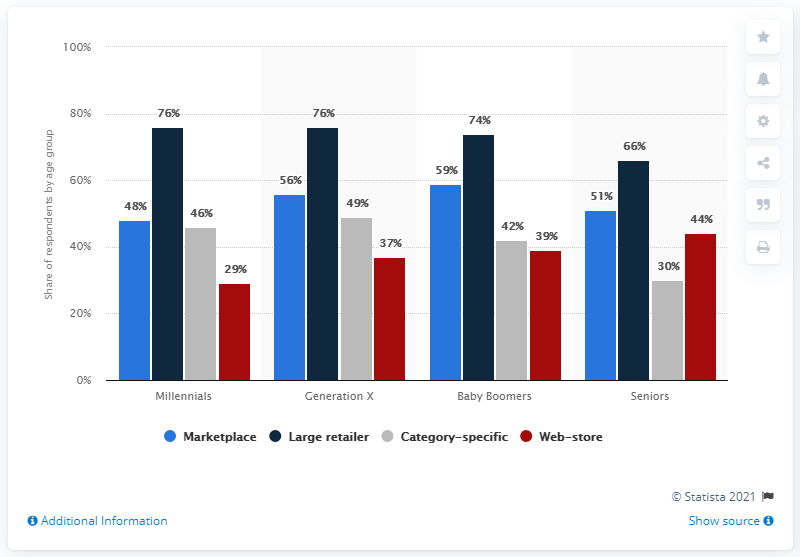List a handful of essential elements in this visual. A significant percentage of Millennials prefer to shop at large retailers, with 76% of them indicating a preference for these types of stores. 